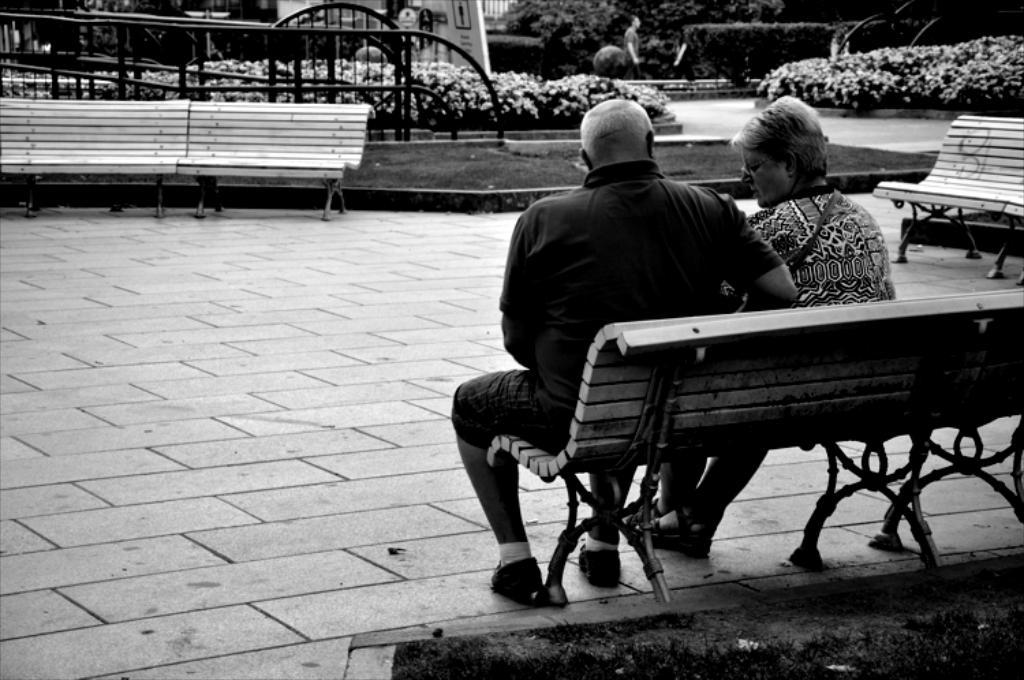Who is present in the image? There is a couple in the image. What are the couple doing in the image? The couple is sitting on a bench. What is the color scheme of the image? The image is black and white. What can be seen in the background of the image? There is a railing and plants in the background of the image. What type of cave can be seen in the background of the image? There is no cave present in the image; it features a couple sitting on a bench with a railing and plants in the background. 